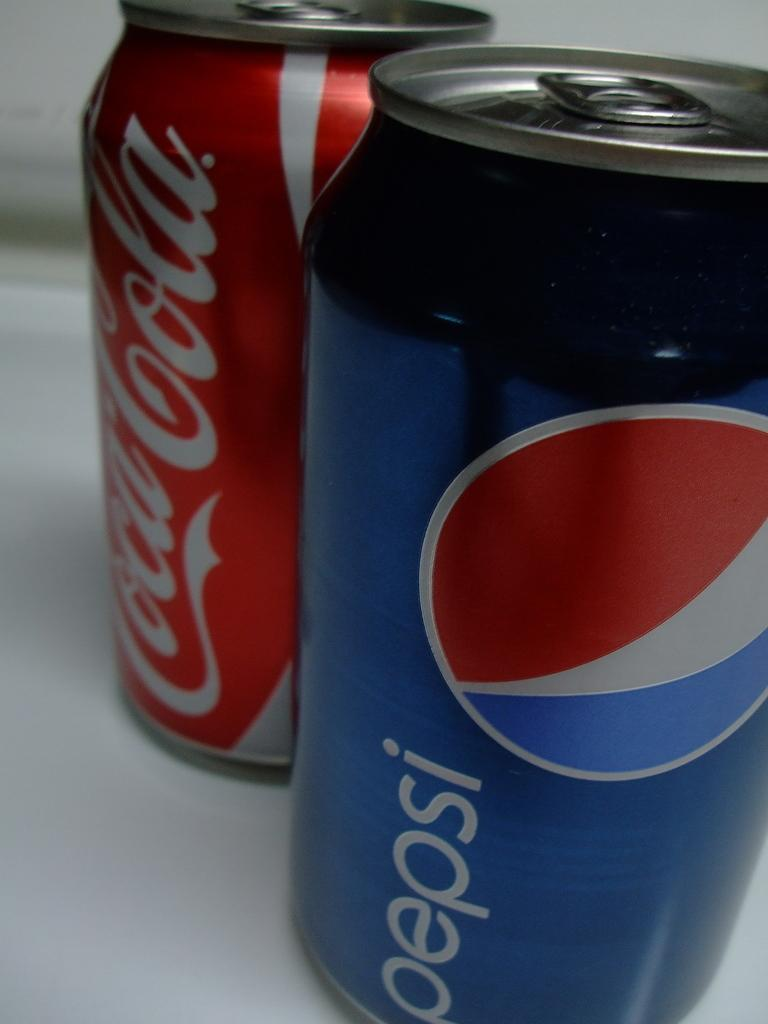<image>
Create a compact narrative representing the image presented. A can of Coca Cola sits next to a can of pepsi 